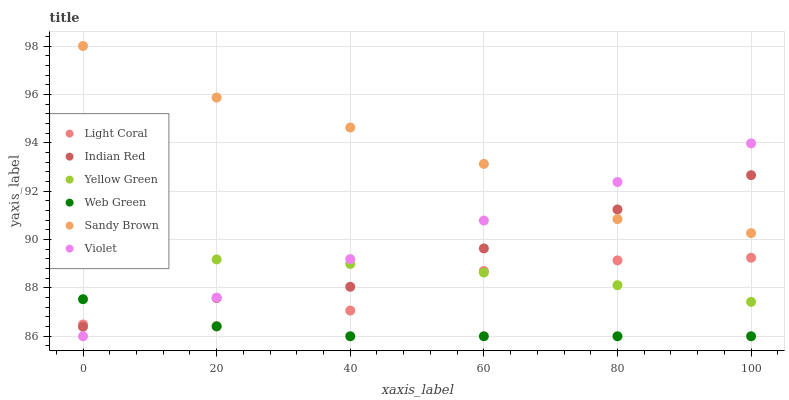Does Web Green have the minimum area under the curve?
Answer yes or no. Yes. Does Sandy Brown have the maximum area under the curve?
Answer yes or no. Yes. Does Light Coral have the minimum area under the curve?
Answer yes or no. No. Does Light Coral have the maximum area under the curve?
Answer yes or no. No. Is Violet the smoothest?
Answer yes or no. Yes. Is Sandy Brown the roughest?
Answer yes or no. Yes. Is Web Green the smoothest?
Answer yes or no. No. Is Web Green the roughest?
Answer yes or no. No. Does Web Green have the lowest value?
Answer yes or no. Yes. Does Light Coral have the lowest value?
Answer yes or no. No. Does Sandy Brown have the highest value?
Answer yes or no. Yes. Does Light Coral have the highest value?
Answer yes or no. No. Is Web Green less than Yellow Green?
Answer yes or no. Yes. Is Yellow Green greater than Web Green?
Answer yes or no. Yes. Does Yellow Green intersect Violet?
Answer yes or no. Yes. Is Yellow Green less than Violet?
Answer yes or no. No. Is Yellow Green greater than Violet?
Answer yes or no. No. Does Web Green intersect Yellow Green?
Answer yes or no. No. 